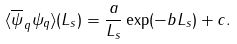Convert formula to latex. <formula><loc_0><loc_0><loc_500><loc_500>\langle \overline { \psi } _ { q } \psi _ { q } \rangle ( L _ { s } ) = \frac { a } { L _ { s } } \exp ( - b L _ { s } ) + c .</formula> 